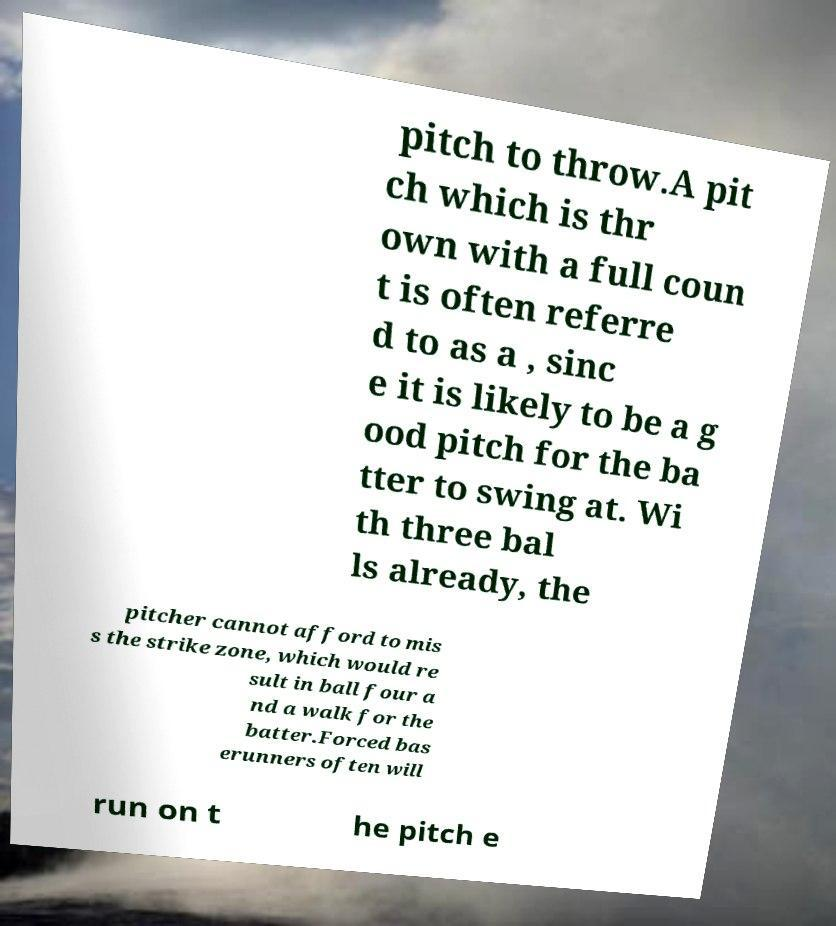Could you assist in decoding the text presented in this image and type it out clearly? pitch to throw.A pit ch which is thr own with a full coun t is often referre d to as a , sinc e it is likely to be a g ood pitch for the ba tter to swing at. Wi th three bal ls already, the pitcher cannot afford to mis s the strike zone, which would re sult in ball four a nd a walk for the batter.Forced bas erunners often will run on t he pitch e 